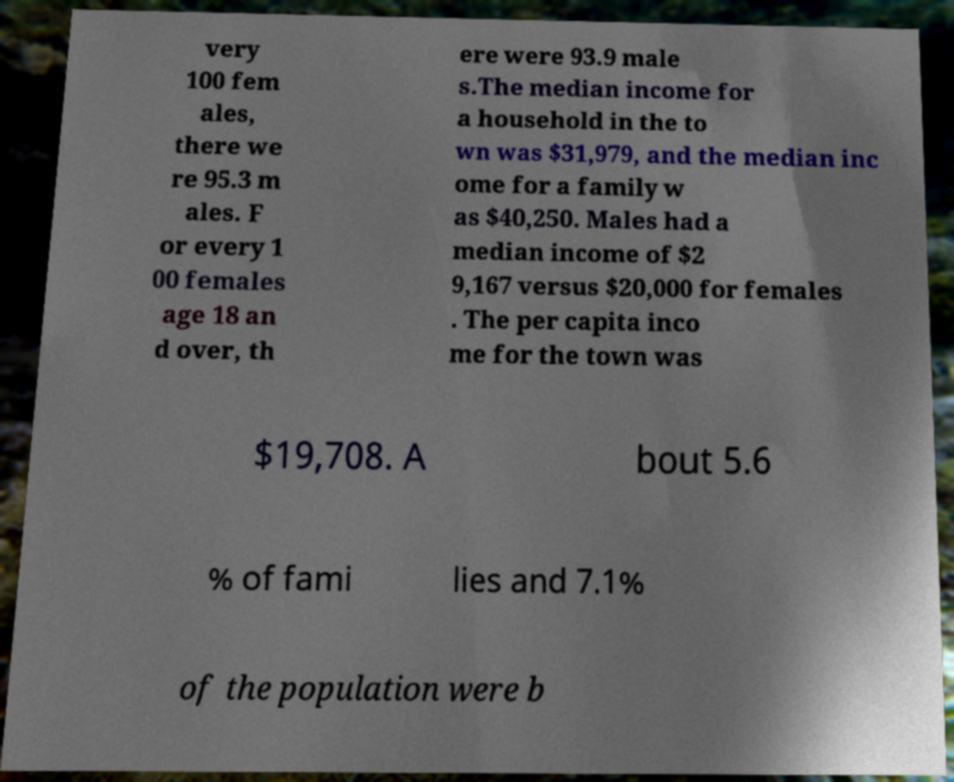Could you assist in decoding the text presented in this image and type it out clearly? very 100 fem ales, there we re 95.3 m ales. F or every 1 00 females age 18 an d over, th ere were 93.9 male s.The median income for a household in the to wn was $31,979, and the median inc ome for a family w as $40,250. Males had a median income of $2 9,167 versus $20,000 for females . The per capita inco me for the town was $19,708. A bout 5.6 % of fami lies and 7.1% of the population were b 